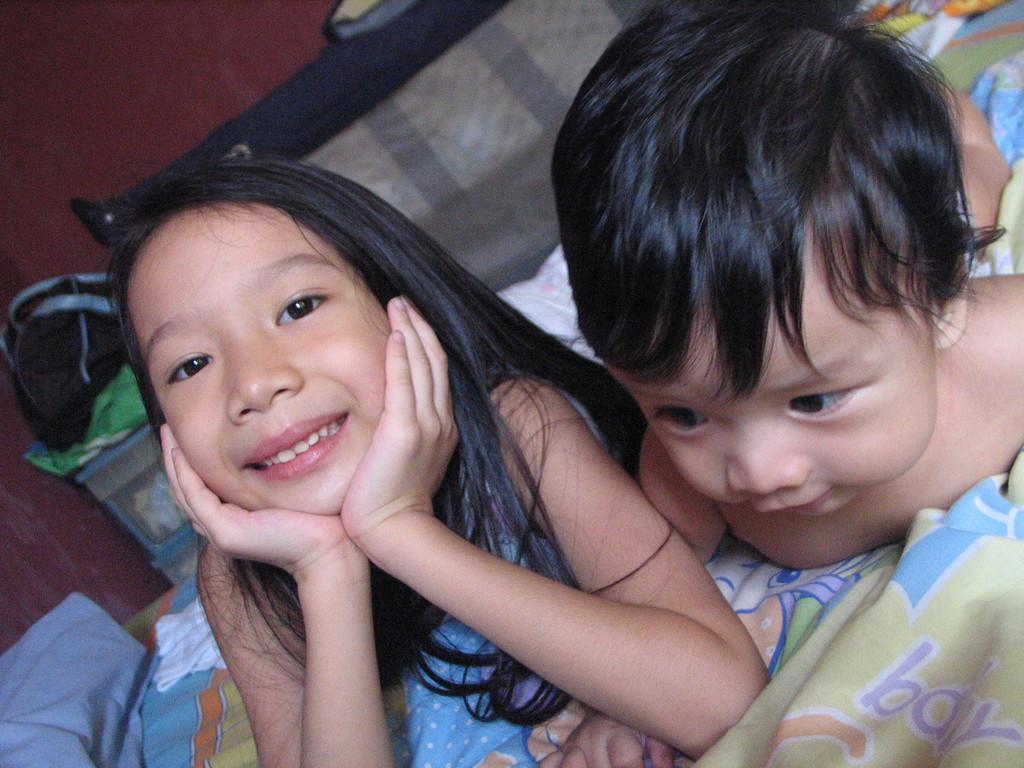Who is present in the image? There is a girl and a baby in the image. Where are the girl and the baby located? Both the girl and the baby are on a bed. What can be seen in the background of the image? There is a wall in the background of the image. What object is visible on the left side of the image? There appears to be a bag on the left side of the image. Is there a fan blowing air on the girl and the baby in the image? There is no fan visible in the image, so it cannot be determined if air is being blown on the girl and the baby. 